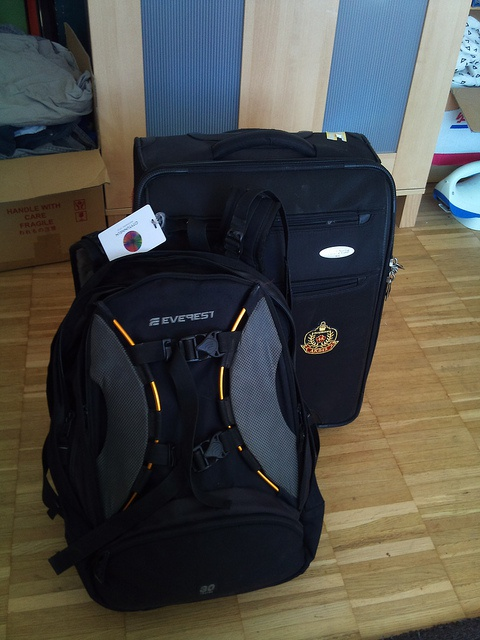Describe the objects in this image and their specific colors. I can see backpack in black, gray, and darkblue tones and suitcase in black, navy, blue, and darkgray tones in this image. 